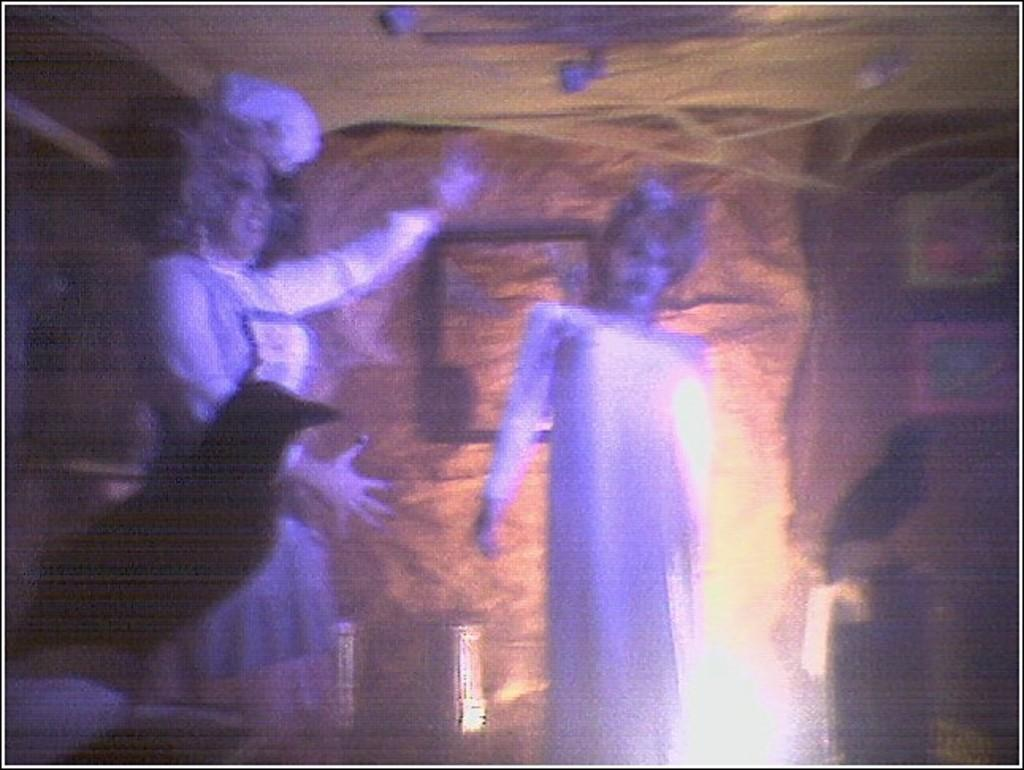How many people are in the image? There are two persons in the middle of the image. What is located in the front of the image? There is a bird in the front of the image. Can you describe the background of the image? The background of the image is blurry. What type of pies is the monkey holding in the image? There is no monkey or pies present in the image. 